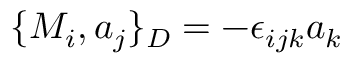<formula> <loc_0><loc_0><loc_500><loc_500>\{ M _ { i } , a _ { j } \} _ { D } = - \epsilon _ { i j k } a _ { k }</formula> 